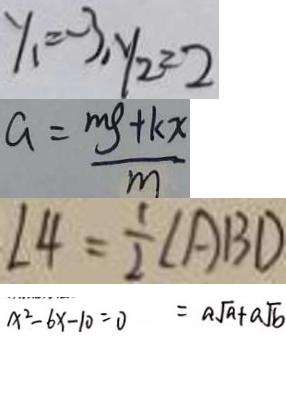<formula> <loc_0><loc_0><loc_500><loc_500>y _ { 1 } = - 3 , y _ { 2 } = 2 
 a = \frac { m g + k x } { m } 
 \angle 4 = \frac { 1 } { 2 } \angle A B D 
 x ^ { 2 } - 6 x - 1 0 = 0 = a \sqrt { a } + a \sqrt { b }</formula> 